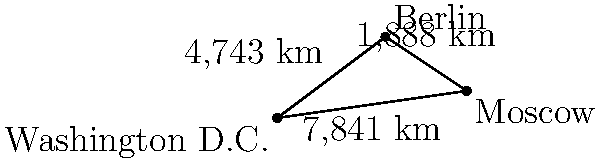In the context of international diplomacy, consider the capitals Washington D.C., Berlin, and Moscow represented as points on a plane. Given the distances between Washington D.C. and Berlin (4,743 km), Berlin and Moscow (1,888 km), and Washington D.C. and Moscow (7,841 km), determine whether traveling from Washington D.C. to Moscow directly is shorter than going through Berlin. What geopolitical implications might this have for diplomatic relations and travel routes? To solve this problem, we need to compare the direct distance between Washington D.C. and Moscow with the sum of the distances from Washington D.C. to Berlin and from Berlin to Moscow.

Step 1: Identify the given distances
- Washington D.C. to Berlin: 4,743 km
- Berlin to Moscow: 1,888 km
- Washington D.C. to Moscow (direct): 7,841 km

Step 2: Calculate the total distance of the route through Berlin
Total distance = Washington D.C. to Berlin + Berlin to Moscow
$$ 4,743 \text{ km} + 1,888 \text{ km} = 6,631 \text{ km} $$

Step 3: Compare the distances
Direct route: 7,841 km
Route through Berlin: 6,631 km

Step 4: Determine the shorter route
The route through Berlin (6,631 km) is shorter than the direct route (7,841 km) by 1,210 km.

Geopolitical implications:
1. Increased importance of Berlin as a diplomatic hub for U.S.-Russia relations.
2. Potential for more frequent stopovers in Berlin for diplomats and officials traveling between the U.S. and Russia.
3. Enhanced opportunity for Germany to play a mediating role in U.S.-Russia affairs.
4. Possible economic benefits for Germany due to increased diplomatic traffic.
5. Greater complexity in maintaining secure communication channels over a two-leg journey.
6. Potential for triangular diplomacy, with Germany having more influence in U.S.-Russia interactions.
Answer: The route through Berlin is shorter by 1,210 km, potentially increasing Berlin's diplomatic importance. 